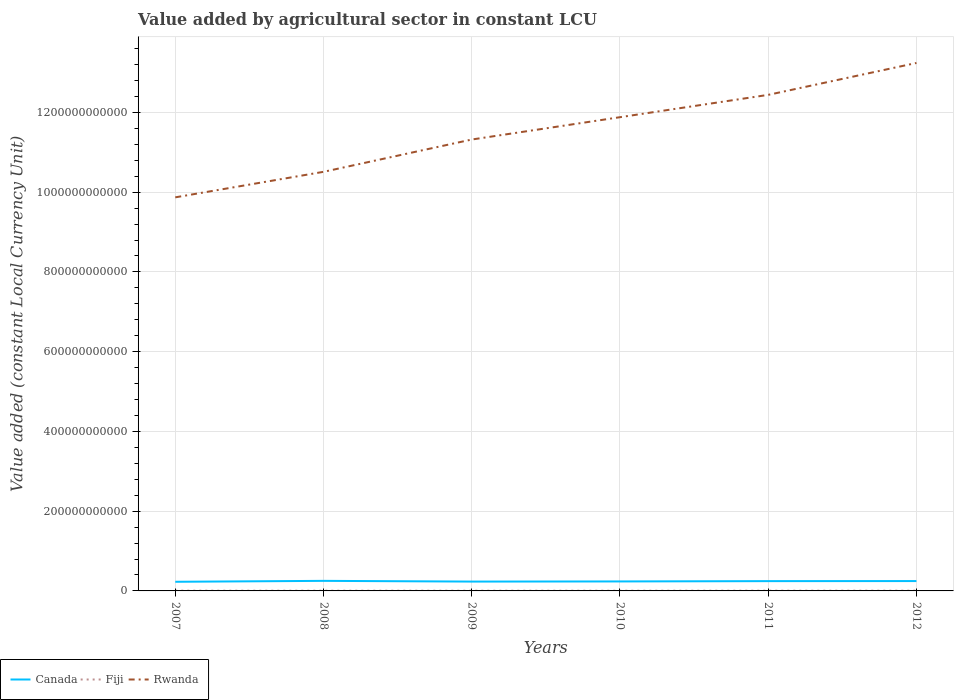Does the line corresponding to Rwanda intersect with the line corresponding to Canada?
Your answer should be very brief. No. Is the number of lines equal to the number of legend labels?
Give a very brief answer. Yes. Across all years, what is the maximum value added by agricultural sector in Fiji?
Your answer should be compact. 5.37e+08. In which year was the value added by agricultural sector in Canada maximum?
Give a very brief answer. 2007. What is the total value added by agricultural sector in Fiji in the graph?
Give a very brief answer. -1.62e+07. What is the difference between the highest and the second highest value added by agricultural sector in Fiji?
Make the answer very short. 8.65e+07. What is the difference between two consecutive major ticks on the Y-axis?
Offer a very short reply. 2.00e+11. Does the graph contain grids?
Provide a short and direct response. Yes. What is the title of the graph?
Ensure brevity in your answer.  Value added by agricultural sector in constant LCU. What is the label or title of the Y-axis?
Offer a very short reply. Value added (constant Local Currency Unit). What is the Value added (constant Local Currency Unit) in Canada in 2007?
Make the answer very short. 2.29e+1. What is the Value added (constant Local Currency Unit) of Fiji in 2007?
Ensure brevity in your answer.  6.08e+08. What is the Value added (constant Local Currency Unit) of Rwanda in 2007?
Provide a short and direct response. 9.87e+11. What is the Value added (constant Local Currency Unit) of Canada in 2008?
Make the answer very short. 2.52e+1. What is the Value added (constant Local Currency Unit) of Fiji in 2008?
Your answer should be compact. 6.01e+08. What is the Value added (constant Local Currency Unit) in Rwanda in 2008?
Provide a succinct answer. 1.05e+12. What is the Value added (constant Local Currency Unit) of Canada in 2009?
Offer a terse response. 2.34e+1. What is the Value added (constant Local Currency Unit) in Fiji in 2009?
Give a very brief answer. 5.52e+08. What is the Value added (constant Local Currency Unit) of Rwanda in 2009?
Offer a very short reply. 1.13e+12. What is the Value added (constant Local Currency Unit) of Canada in 2010?
Ensure brevity in your answer.  2.38e+1. What is the Value added (constant Local Currency Unit) in Fiji in 2010?
Provide a succinct answer. 5.37e+08. What is the Value added (constant Local Currency Unit) of Rwanda in 2010?
Ensure brevity in your answer.  1.19e+12. What is the Value added (constant Local Currency Unit) of Canada in 2011?
Your response must be concise. 2.46e+1. What is the Value added (constant Local Currency Unit) in Fiji in 2011?
Provide a short and direct response. 6.24e+08. What is the Value added (constant Local Currency Unit) in Rwanda in 2011?
Provide a succinct answer. 1.24e+12. What is the Value added (constant Local Currency Unit) in Canada in 2012?
Your answer should be very brief. 2.47e+1. What is the Value added (constant Local Currency Unit) of Fiji in 2012?
Your answer should be compact. 6.12e+08. What is the Value added (constant Local Currency Unit) of Rwanda in 2012?
Offer a very short reply. 1.32e+12. Across all years, what is the maximum Value added (constant Local Currency Unit) in Canada?
Give a very brief answer. 2.52e+1. Across all years, what is the maximum Value added (constant Local Currency Unit) in Fiji?
Make the answer very short. 6.24e+08. Across all years, what is the maximum Value added (constant Local Currency Unit) in Rwanda?
Offer a very short reply. 1.32e+12. Across all years, what is the minimum Value added (constant Local Currency Unit) in Canada?
Your response must be concise. 2.29e+1. Across all years, what is the minimum Value added (constant Local Currency Unit) of Fiji?
Your answer should be compact. 5.37e+08. Across all years, what is the minimum Value added (constant Local Currency Unit) of Rwanda?
Your answer should be very brief. 9.87e+11. What is the total Value added (constant Local Currency Unit) in Canada in the graph?
Provide a short and direct response. 1.45e+11. What is the total Value added (constant Local Currency Unit) in Fiji in the graph?
Your answer should be very brief. 3.53e+09. What is the total Value added (constant Local Currency Unit) in Rwanda in the graph?
Offer a very short reply. 6.93e+12. What is the difference between the Value added (constant Local Currency Unit) of Canada in 2007 and that in 2008?
Your response must be concise. -2.30e+09. What is the difference between the Value added (constant Local Currency Unit) in Fiji in 2007 and that in 2008?
Ensure brevity in your answer.  7.05e+06. What is the difference between the Value added (constant Local Currency Unit) in Rwanda in 2007 and that in 2008?
Provide a succinct answer. -6.40e+1. What is the difference between the Value added (constant Local Currency Unit) of Canada in 2007 and that in 2009?
Provide a succinct answer. -4.77e+08. What is the difference between the Value added (constant Local Currency Unit) in Fiji in 2007 and that in 2009?
Provide a succinct answer. 5.56e+07. What is the difference between the Value added (constant Local Currency Unit) of Rwanda in 2007 and that in 2009?
Make the answer very short. -1.45e+11. What is the difference between the Value added (constant Local Currency Unit) of Canada in 2007 and that in 2010?
Keep it short and to the point. -8.49e+08. What is the difference between the Value added (constant Local Currency Unit) of Fiji in 2007 and that in 2010?
Your answer should be very brief. 7.03e+07. What is the difference between the Value added (constant Local Currency Unit) of Rwanda in 2007 and that in 2010?
Keep it short and to the point. -2.01e+11. What is the difference between the Value added (constant Local Currency Unit) of Canada in 2007 and that in 2011?
Offer a very short reply. -1.64e+09. What is the difference between the Value added (constant Local Currency Unit) in Fiji in 2007 and that in 2011?
Provide a succinct answer. -1.62e+07. What is the difference between the Value added (constant Local Currency Unit) in Rwanda in 2007 and that in 2011?
Make the answer very short. -2.57e+11. What is the difference between the Value added (constant Local Currency Unit) in Canada in 2007 and that in 2012?
Provide a short and direct response. -1.80e+09. What is the difference between the Value added (constant Local Currency Unit) of Fiji in 2007 and that in 2012?
Provide a short and direct response. -4.00e+06. What is the difference between the Value added (constant Local Currency Unit) of Rwanda in 2007 and that in 2012?
Provide a short and direct response. -3.37e+11. What is the difference between the Value added (constant Local Currency Unit) of Canada in 2008 and that in 2009?
Provide a succinct answer. 1.82e+09. What is the difference between the Value added (constant Local Currency Unit) in Fiji in 2008 and that in 2009?
Your response must be concise. 4.86e+07. What is the difference between the Value added (constant Local Currency Unit) in Rwanda in 2008 and that in 2009?
Make the answer very short. -8.10e+1. What is the difference between the Value added (constant Local Currency Unit) in Canada in 2008 and that in 2010?
Offer a terse response. 1.45e+09. What is the difference between the Value added (constant Local Currency Unit) of Fiji in 2008 and that in 2010?
Offer a terse response. 6.32e+07. What is the difference between the Value added (constant Local Currency Unit) in Rwanda in 2008 and that in 2010?
Ensure brevity in your answer.  -1.37e+11. What is the difference between the Value added (constant Local Currency Unit) in Canada in 2008 and that in 2011?
Your answer should be compact. 6.58e+08. What is the difference between the Value added (constant Local Currency Unit) in Fiji in 2008 and that in 2011?
Offer a very short reply. -2.32e+07. What is the difference between the Value added (constant Local Currency Unit) of Rwanda in 2008 and that in 2011?
Give a very brief answer. -1.93e+11. What is the difference between the Value added (constant Local Currency Unit) of Canada in 2008 and that in 2012?
Your answer should be very brief. 4.92e+08. What is the difference between the Value added (constant Local Currency Unit) in Fiji in 2008 and that in 2012?
Your response must be concise. -1.10e+07. What is the difference between the Value added (constant Local Currency Unit) of Rwanda in 2008 and that in 2012?
Keep it short and to the point. -2.73e+11. What is the difference between the Value added (constant Local Currency Unit) in Canada in 2009 and that in 2010?
Ensure brevity in your answer.  -3.73e+08. What is the difference between the Value added (constant Local Currency Unit) in Fiji in 2009 and that in 2010?
Provide a succinct answer. 1.46e+07. What is the difference between the Value added (constant Local Currency Unit) in Rwanda in 2009 and that in 2010?
Make the answer very short. -5.60e+1. What is the difference between the Value added (constant Local Currency Unit) of Canada in 2009 and that in 2011?
Your answer should be compact. -1.16e+09. What is the difference between the Value added (constant Local Currency Unit) in Fiji in 2009 and that in 2011?
Your answer should be compact. -7.18e+07. What is the difference between the Value added (constant Local Currency Unit) of Rwanda in 2009 and that in 2011?
Offer a very short reply. -1.12e+11. What is the difference between the Value added (constant Local Currency Unit) of Canada in 2009 and that in 2012?
Ensure brevity in your answer.  -1.33e+09. What is the difference between the Value added (constant Local Currency Unit) of Fiji in 2009 and that in 2012?
Your answer should be compact. -5.96e+07. What is the difference between the Value added (constant Local Currency Unit) in Rwanda in 2009 and that in 2012?
Provide a short and direct response. -1.92e+11. What is the difference between the Value added (constant Local Currency Unit) of Canada in 2010 and that in 2011?
Provide a short and direct response. -7.89e+08. What is the difference between the Value added (constant Local Currency Unit) of Fiji in 2010 and that in 2011?
Provide a short and direct response. -8.65e+07. What is the difference between the Value added (constant Local Currency Unit) of Rwanda in 2010 and that in 2011?
Keep it short and to the point. -5.60e+1. What is the difference between the Value added (constant Local Currency Unit) in Canada in 2010 and that in 2012?
Provide a succinct answer. -9.55e+08. What is the difference between the Value added (constant Local Currency Unit) of Fiji in 2010 and that in 2012?
Provide a succinct answer. -7.43e+07. What is the difference between the Value added (constant Local Currency Unit) of Rwanda in 2010 and that in 2012?
Ensure brevity in your answer.  -1.36e+11. What is the difference between the Value added (constant Local Currency Unit) in Canada in 2011 and that in 2012?
Provide a short and direct response. -1.67e+08. What is the difference between the Value added (constant Local Currency Unit) in Fiji in 2011 and that in 2012?
Keep it short and to the point. 1.22e+07. What is the difference between the Value added (constant Local Currency Unit) in Rwanda in 2011 and that in 2012?
Keep it short and to the point. -8.00e+1. What is the difference between the Value added (constant Local Currency Unit) of Canada in 2007 and the Value added (constant Local Currency Unit) of Fiji in 2008?
Provide a short and direct response. 2.23e+1. What is the difference between the Value added (constant Local Currency Unit) in Canada in 2007 and the Value added (constant Local Currency Unit) in Rwanda in 2008?
Your answer should be compact. -1.03e+12. What is the difference between the Value added (constant Local Currency Unit) of Fiji in 2007 and the Value added (constant Local Currency Unit) of Rwanda in 2008?
Give a very brief answer. -1.05e+12. What is the difference between the Value added (constant Local Currency Unit) in Canada in 2007 and the Value added (constant Local Currency Unit) in Fiji in 2009?
Offer a terse response. 2.24e+1. What is the difference between the Value added (constant Local Currency Unit) in Canada in 2007 and the Value added (constant Local Currency Unit) in Rwanda in 2009?
Provide a short and direct response. -1.11e+12. What is the difference between the Value added (constant Local Currency Unit) of Fiji in 2007 and the Value added (constant Local Currency Unit) of Rwanda in 2009?
Your answer should be compact. -1.13e+12. What is the difference between the Value added (constant Local Currency Unit) in Canada in 2007 and the Value added (constant Local Currency Unit) in Fiji in 2010?
Your answer should be compact. 2.24e+1. What is the difference between the Value added (constant Local Currency Unit) in Canada in 2007 and the Value added (constant Local Currency Unit) in Rwanda in 2010?
Provide a succinct answer. -1.17e+12. What is the difference between the Value added (constant Local Currency Unit) in Fiji in 2007 and the Value added (constant Local Currency Unit) in Rwanda in 2010?
Keep it short and to the point. -1.19e+12. What is the difference between the Value added (constant Local Currency Unit) of Canada in 2007 and the Value added (constant Local Currency Unit) of Fiji in 2011?
Your response must be concise. 2.23e+1. What is the difference between the Value added (constant Local Currency Unit) of Canada in 2007 and the Value added (constant Local Currency Unit) of Rwanda in 2011?
Offer a terse response. -1.22e+12. What is the difference between the Value added (constant Local Currency Unit) in Fiji in 2007 and the Value added (constant Local Currency Unit) in Rwanda in 2011?
Offer a very short reply. -1.24e+12. What is the difference between the Value added (constant Local Currency Unit) in Canada in 2007 and the Value added (constant Local Currency Unit) in Fiji in 2012?
Your answer should be compact. 2.23e+1. What is the difference between the Value added (constant Local Currency Unit) in Canada in 2007 and the Value added (constant Local Currency Unit) in Rwanda in 2012?
Offer a terse response. -1.30e+12. What is the difference between the Value added (constant Local Currency Unit) of Fiji in 2007 and the Value added (constant Local Currency Unit) of Rwanda in 2012?
Provide a short and direct response. -1.32e+12. What is the difference between the Value added (constant Local Currency Unit) in Canada in 2008 and the Value added (constant Local Currency Unit) in Fiji in 2009?
Your answer should be compact. 2.47e+1. What is the difference between the Value added (constant Local Currency Unit) of Canada in 2008 and the Value added (constant Local Currency Unit) of Rwanda in 2009?
Give a very brief answer. -1.11e+12. What is the difference between the Value added (constant Local Currency Unit) in Fiji in 2008 and the Value added (constant Local Currency Unit) in Rwanda in 2009?
Your answer should be very brief. -1.13e+12. What is the difference between the Value added (constant Local Currency Unit) of Canada in 2008 and the Value added (constant Local Currency Unit) of Fiji in 2010?
Provide a succinct answer. 2.47e+1. What is the difference between the Value added (constant Local Currency Unit) of Canada in 2008 and the Value added (constant Local Currency Unit) of Rwanda in 2010?
Provide a short and direct response. -1.16e+12. What is the difference between the Value added (constant Local Currency Unit) of Fiji in 2008 and the Value added (constant Local Currency Unit) of Rwanda in 2010?
Give a very brief answer. -1.19e+12. What is the difference between the Value added (constant Local Currency Unit) of Canada in 2008 and the Value added (constant Local Currency Unit) of Fiji in 2011?
Offer a very short reply. 2.46e+1. What is the difference between the Value added (constant Local Currency Unit) in Canada in 2008 and the Value added (constant Local Currency Unit) in Rwanda in 2011?
Provide a short and direct response. -1.22e+12. What is the difference between the Value added (constant Local Currency Unit) in Fiji in 2008 and the Value added (constant Local Currency Unit) in Rwanda in 2011?
Give a very brief answer. -1.24e+12. What is the difference between the Value added (constant Local Currency Unit) of Canada in 2008 and the Value added (constant Local Currency Unit) of Fiji in 2012?
Keep it short and to the point. 2.46e+1. What is the difference between the Value added (constant Local Currency Unit) of Canada in 2008 and the Value added (constant Local Currency Unit) of Rwanda in 2012?
Your answer should be compact. -1.30e+12. What is the difference between the Value added (constant Local Currency Unit) in Fiji in 2008 and the Value added (constant Local Currency Unit) in Rwanda in 2012?
Your response must be concise. -1.32e+12. What is the difference between the Value added (constant Local Currency Unit) in Canada in 2009 and the Value added (constant Local Currency Unit) in Fiji in 2010?
Give a very brief answer. 2.29e+1. What is the difference between the Value added (constant Local Currency Unit) in Canada in 2009 and the Value added (constant Local Currency Unit) in Rwanda in 2010?
Give a very brief answer. -1.16e+12. What is the difference between the Value added (constant Local Currency Unit) in Fiji in 2009 and the Value added (constant Local Currency Unit) in Rwanda in 2010?
Provide a succinct answer. -1.19e+12. What is the difference between the Value added (constant Local Currency Unit) in Canada in 2009 and the Value added (constant Local Currency Unit) in Fiji in 2011?
Provide a short and direct response. 2.28e+1. What is the difference between the Value added (constant Local Currency Unit) of Canada in 2009 and the Value added (constant Local Currency Unit) of Rwanda in 2011?
Offer a terse response. -1.22e+12. What is the difference between the Value added (constant Local Currency Unit) in Fiji in 2009 and the Value added (constant Local Currency Unit) in Rwanda in 2011?
Offer a very short reply. -1.24e+12. What is the difference between the Value added (constant Local Currency Unit) of Canada in 2009 and the Value added (constant Local Currency Unit) of Fiji in 2012?
Make the answer very short. 2.28e+1. What is the difference between the Value added (constant Local Currency Unit) of Canada in 2009 and the Value added (constant Local Currency Unit) of Rwanda in 2012?
Offer a terse response. -1.30e+12. What is the difference between the Value added (constant Local Currency Unit) in Fiji in 2009 and the Value added (constant Local Currency Unit) in Rwanda in 2012?
Give a very brief answer. -1.32e+12. What is the difference between the Value added (constant Local Currency Unit) of Canada in 2010 and the Value added (constant Local Currency Unit) of Fiji in 2011?
Your answer should be very brief. 2.32e+1. What is the difference between the Value added (constant Local Currency Unit) of Canada in 2010 and the Value added (constant Local Currency Unit) of Rwanda in 2011?
Provide a short and direct response. -1.22e+12. What is the difference between the Value added (constant Local Currency Unit) of Fiji in 2010 and the Value added (constant Local Currency Unit) of Rwanda in 2011?
Ensure brevity in your answer.  -1.24e+12. What is the difference between the Value added (constant Local Currency Unit) in Canada in 2010 and the Value added (constant Local Currency Unit) in Fiji in 2012?
Ensure brevity in your answer.  2.32e+1. What is the difference between the Value added (constant Local Currency Unit) of Canada in 2010 and the Value added (constant Local Currency Unit) of Rwanda in 2012?
Provide a succinct answer. -1.30e+12. What is the difference between the Value added (constant Local Currency Unit) of Fiji in 2010 and the Value added (constant Local Currency Unit) of Rwanda in 2012?
Provide a succinct answer. -1.32e+12. What is the difference between the Value added (constant Local Currency Unit) of Canada in 2011 and the Value added (constant Local Currency Unit) of Fiji in 2012?
Make the answer very short. 2.40e+1. What is the difference between the Value added (constant Local Currency Unit) of Canada in 2011 and the Value added (constant Local Currency Unit) of Rwanda in 2012?
Offer a very short reply. -1.30e+12. What is the difference between the Value added (constant Local Currency Unit) of Fiji in 2011 and the Value added (constant Local Currency Unit) of Rwanda in 2012?
Your response must be concise. -1.32e+12. What is the average Value added (constant Local Currency Unit) in Canada per year?
Offer a terse response. 2.41e+1. What is the average Value added (constant Local Currency Unit) in Fiji per year?
Keep it short and to the point. 5.89e+08. What is the average Value added (constant Local Currency Unit) in Rwanda per year?
Your response must be concise. 1.15e+12. In the year 2007, what is the difference between the Value added (constant Local Currency Unit) of Canada and Value added (constant Local Currency Unit) of Fiji?
Make the answer very short. 2.23e+1. In the year 2007, what is the difference between the Value added (constant Local Currency Unit) of Canada and Value added (constant Local Currency Unit) of Rwanda?
Give a very brief answer. -9.64e+11. In the year 2007, what is the difference between the Value added (constant Local Currency Unit) of Fiji and Value added (constant Local Currency Unit) of Rwanda?
Offer a terse response. -9.86e+11. In the year 2008, what is the difference between the Value added (constant Local Currency Unit) of Canada and Value added (constant Local Currency Unit) of Fiji?
Provide a short and direct response. 2.46e+1. In the year 2008, what is the difference between the Value added (constant Local Currency Unit) of Canada and Value added (constant Local Currency Unit) of Rwanda?
Your answer should be compact. -1.03e+12. In the year 2008, what is the difference between the Value added (constant Local Currency Unit) of Fiji and Value added (constant Local Currency Unit) of Rwanda?
Ensure brevity in your answer.  -1.05e+12. In the year 2009, what is the difference between the Value added (constant Local Currency Unit) of Canada and Value added (constant Local Currency Unit) of Fiji?
Provide a short and direct response. 2.29e+1. In the year 2009, what is the difference between the Value added (constant Local Currency Unit) in Canada and Value added (constant Local Currency Unit) in Rwanda?
Ensure brevity in your answer.  -1.11e+12. In the year 2009, what is the difference between the Value added (constant Local Currency Unit) in Fiji and Value added (constant Local Currency Unit) in Rwanda?
Offer a terse response. -1.13e+12. In the year 2010, what is the difference between the Value added (constant Local Currency Unit) in Canada and Value added (constant Local Currency Unit) in Fiji?
Keep it short and to the point. 2.32e+1. In the year 2010, what is the difference between the Value added (constant Local Currency Unit) of Canada and Value added (constant Local Currency Unit) of Rwanda?
Keep it short and to the point. -1.16e+12. In the year 2010, what is the difference between the Value added (constant Local Currency Unit) of Fiji and Value added (constant Local Currency Unit) of Rwanda?
Offer a terse response. -1.19e+12. In the year 2011, what is the difference between the Value added (constant Local Currency Unit) of Canada and Value added (constant Local Currency Unit) of Fiji?
Your response must be concise. 2.40e+1. In the year 2011, what is the difference between the Value added (constant Local Currency Unit) in Canada and Value added (constant Local Currency Unit) in Rwanda?
Your answer should be very brief. -1.22e+12. In the year 2011, what is the difference between the Value added (constant Local Currency Unit) of Fiji and Value added (constant Local Currency Unit) of Rwanda?
Provide a short and direct response. -1.24e+12. In the year 2012, what is the difference between the Value added (constant Local Currency Unit) of Canada and Value added (constant Local Currency Unit) of Fiji?
Your answer should be compact. 2.41e+1. In the year 2012, what is the difference between the Value added (constant Local Currency Unit) of Canada and Value added (constant Local Currency Unit) of Rwanda?
Provide a short and direct response. -1.30e+12. In the year 2012, what is the difference between the Value added (constant Local Currency Unit) in Fiji and Value added (constant Local Currency Unit) in Rwanda?
Your answer should be compact. -1.32e+12. What is the ratio of the Value added (constant Local Currency Unit) in Canada in 2007 to that in 2008?
Your answer should be very brief. 0.91. What is the ratio of the Value added (constant Local Currency Unit) in Fiji in 2007 to that in 2008?
Your answer should be very brief. 1.01. What is the ratio of the Value added (constant Local Currency Unit) in Rwanda in 2007 to that in 2008?
Your answer should be very brief. 0.94. What is the ratio of the Value added (constant Local Currency Unit) of Canada in 2007 to that in 2009?
Provide a succinct answer. 0.98. What is the ratio of the Value added (constant Local Currency Unit) of Fiji in 2007 to that in 2009?
Your response must be concise. 1.1. What is the ratio of the Value added (constant Local Currency Unit) of Rwanda in 2007 to that in 2009?
Offer a terse response. 0.87. What is the ratio of the Value added (constant Local Currency Unit) in Canada in 2007 to that in 2010?
Your answer should be compact. 0.96. What is the ratio of the Value added (constant Local Currency Unit) of Fiji in 2007 to that in 2010?
Provide a short and direct response. 1.13. What is the ratio of the Value added (constant Local Currency Unit) in Rwanda in 2007 to that in 2010?
Offer a very short reply. 0.83. What is the ratio of the Value added (constant Local Currency Unit) in Fiji in 2007 to that in 2011?
Provide a succinct answer. 0.97. What is the ratio of the Value added (constant Local Currency Unit) of Rwanda in 2007 to that in 2011?
Make the answer very short. 0.79. What is the ratio of the Value added (constant Local Currency Unit) in Canada in 2007 to that in 2012?
Your response must be concise. 0.93. What is the ratio of the Value added (constant Local Currency Unit) in Rwanda in 2007 to that in 2012?
Provide a short and direct response. 0.75. What is the ratio of the Value added (constant Local Currency Unit) in Canada in 2008 to that in 2009?
Give a very brief answer. 1.08. What is the ratio of the Value added (constant Local Currency Unit) in Fiji in 2008 to that in 2009?
Your answer should be very brief. 1.09. What is the ratio of the Value added (constant Local Currency Unit) in Rwanda in 2008 to that in 2009?
Your answer should be very brief. 0.93. What is the ratio of the Value added (constant Local Currency Unit) in Canada in 2008 to that in 2010?
Make the answer very short. 1.06. What is the ratio of the Value added (constant Local Currency Unit) in Fiji in 2008 to that in 2010?
Your response must be concise. 1.12. What is the ratio of the Value added (constant Local Currency Unit) in Rwanda in 2008 to that in 2010?
Provide a short and direct response. 0.88. What is the ratio of the Value added (constant Local Currency Unit) in Canada in 2008 to that in 2011?
Offer a terse response. 1.03. What is the ratio of the Value added (constant Local Currency Unit) of Fiji in 2008 to that in 2011?
Provide a succinct answer. 0.96. What is the ratio of the Value added (constant Local Currency Unit) in Rwanda in 2008 to that in 2011?
Offer a terse response. 0.84. What is the ratio of the Value added (constant Local Currency Unit) in Canada in 2008 to that in 2012?
Offer a terse response. 1.02. What is the ratio of the Value added (constant Local Currency Unit) in Fiji in 2008 to that in 2012?
Provide a succinct answer. 0.98. What is the ratio of the Value added (constant Local Currency Unit) in Rwanda in 2008 to that in 2012?
Your response must be concise. 0.79. What is the ratio of the Value added (constant Local Currency Unit) in Canada in 2009 to that in 2010?
Provide a short and direct response. 0.98. What is the ratio of the Value added (constant Local Currency Unit) in Fiji in 2009 to that in 2010?
Keep it short and to the point. 1.03. What is the ratio of the Value added (constant Local Currency Unit) in Rwanda in 2009 to that in 2010?
Ensure brevity in your answer.  0.95. What is the ratio of the Value added (constant Local Currency Unit) in Canada in 2009 to that in 2011?
Your answer should be compact. 0.95. What is the ratio of the Value added (constant Local Currency Unit) in Fiji in 2009 to that in 2011?
Give a very brief answer. 0.88. What is the ratio of the Value added (constant Local Currency Unit) in Rwanda in 2009 to that in 2011?
Provide a short and direct response. 0.91. What is the ratio of the Value added (constant Local Currency Unit) of Canada in 2009 to that in 2012?
Offer a very short reply. 0.95. What is the ratio of the Value added (constant Local Currency Unit) in Fiji in 2009 to that in 2012?
Make the answer very short. 0.9. What is the ratio of the Value added (constant Local Currency Unit) in Rwanda in 2009 to that in 2012?
Offer a very short reply. 0.85. What is the ratio of the Value added (constant Local Currency Unit) of Canada in 2010 to that in 2011?
Offer a terse response. 0.97. What is the ratio of the Value added (constant Local Currency Unit) in Fiji in 2010 to that in 2011?
Provide a succinct answer. 0.86. What is the ratio of the Value added (constant Local Currency Unit) in Rwanda in 2010 to that in 2011?
Provide a short and direct response. 0.95. What is the ratio of the Value added (constant Local Currency Unit) in Canada in 2010 to that in 2012?
Offer a terse response. 0.96. What is the ratio of the Value added (constant Local Currency Unit) in Fiji in 2010 to that in 2012?
Offer a terse response. 0.88. What is the ratio of the Value added (constant Local Currency Unit) in Rwanda in 2010 to that in 2012?
Give a very brief answer. 0.9. What is the ratio of the Value added (constant Local Currency Unit) in Canada in 2011 to that in 2012?
Make the answer very short. 0.99. What is the ratio of the Value added (constant Local Currency Unit) in Fiji in 2011 to that in 2012?
Your answer should be compact. 1.02. What is the ratio of the Value added (constant Local Currency Unit) of Rwanda in 2011 to that in 2012?
Offer a very short reply. 0.94. What is the difference between the highest and the second highest Value added (constant Local Currency Unit) of Canada?
Your answer should be very brief. 4.92e+08. What is the difference between the highest and the second highest Value added (constant Local Currency Unit) in Fiji?
Give a very brief answer. 1.22e+07. What is the difference between the highest and the second highest Value added (constant Local Currency Unit) of Rwanda?
Give a very brief answer. 8.00e+1. What is the difference between the highest and the lowest Value added (constant Local Currency Unit) in Canada?
Ensure brevity in your answer.  2.30e+09. What is the difference between the highest and the lowest Value added (constant Local Currency Unit) of Fiji?
Keep it short and to the point. 8.65e+07. What is the difference between the highest and the lowest Value added (constant Local Currency Unit) in Rwanda?
Offer a very short reply. 3.37e+11. 